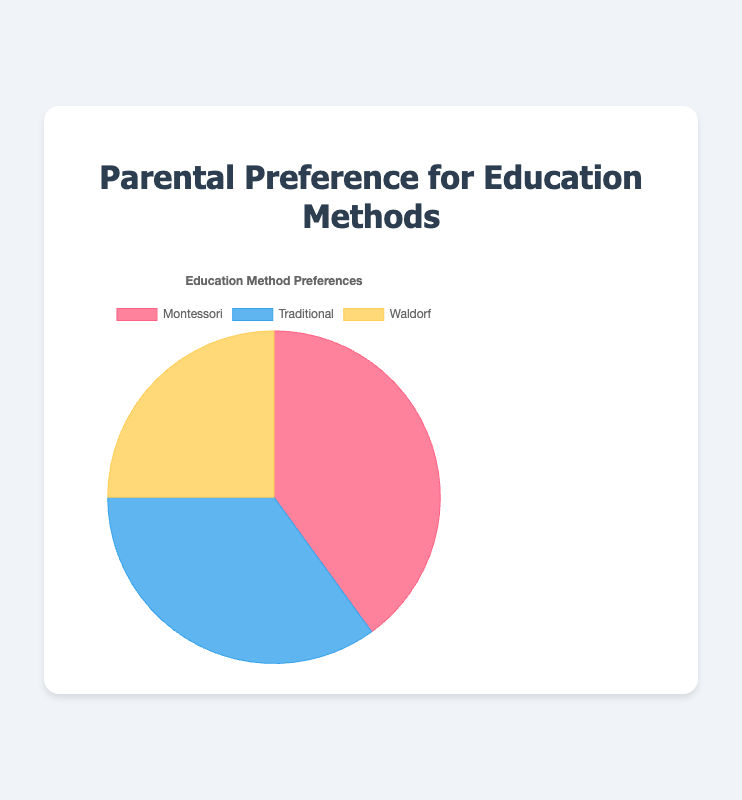What's the most preferred education method? The pie chart shows three education methods and their corresponding percentages. The method with the highest percentage is the most preferred. In this case, Montessori has 40%, Traditional has 35%, and Waldorf has 25%. Thus, Montessori is the most preferred.
Answer: Montessori What's the least preferred education method? To find the least preferred education method, we look at the segment with the lowest percentage in the pie chart. Montessori has 40%, Traditional has 35%, and Waldorf has 25%. Hence, Waldorf is the least preferred.
Answer: Waldorf What's the difference in preference between Montessori and Traditional methods? Montessori has a preference of 40%, and Traditional has a preference of 35%. To find the difference, we subtract 35% from 40%, which gives 5%.
Answer: 5% What percentage of parents prefer either Montessori or Waldorf methods? To find the combined preference for Montessori and Waldorf, we add their percentages: 40% (Montessori) + 25% (Waldorf) = 65%.
Answer: 65% How much more popular is the Montessori method compared to the Waldorf method? Montessori is preferred by 40% of parents, while Waldorf is preferred by 25%. To find how much more popular Montessori is, we subtract 25% from 40%, giving us 15%.
Answer: 15% Is the preference for the Traditional method greater than or equal to the preference for the Waldorf method? The Traditional method has a preference of 35%, while the Waldorf method has a preference of 25%. Since 35% is greater than 25%, the preference for the Traditional method is indeed greater.
Answer: Yes What is the average preference percentage among the three education methods? To find the average preference, we add up the percentages of Montessori (40%), Traditional (35%), and Waldorf (25%) and then divide by the number of methods: (40 + 35 + 25) / 3 = 33.3%.
Answer: 33.3% If 1000 parents were surveyed, how many preferred the Montessori method? Given 1000 parents surveyed and 40% preference for Montessori, we calculate the number of parents by multiplying 1000 by 0.40: 1000 * 0.40 = 400 parents.
Answer: 400 parents Which segment is represented by the blue color in the pie chart? By examining the colors associated with each segment, we identify that the Traditional method is represented by the blue color.
Answer: Traditional 